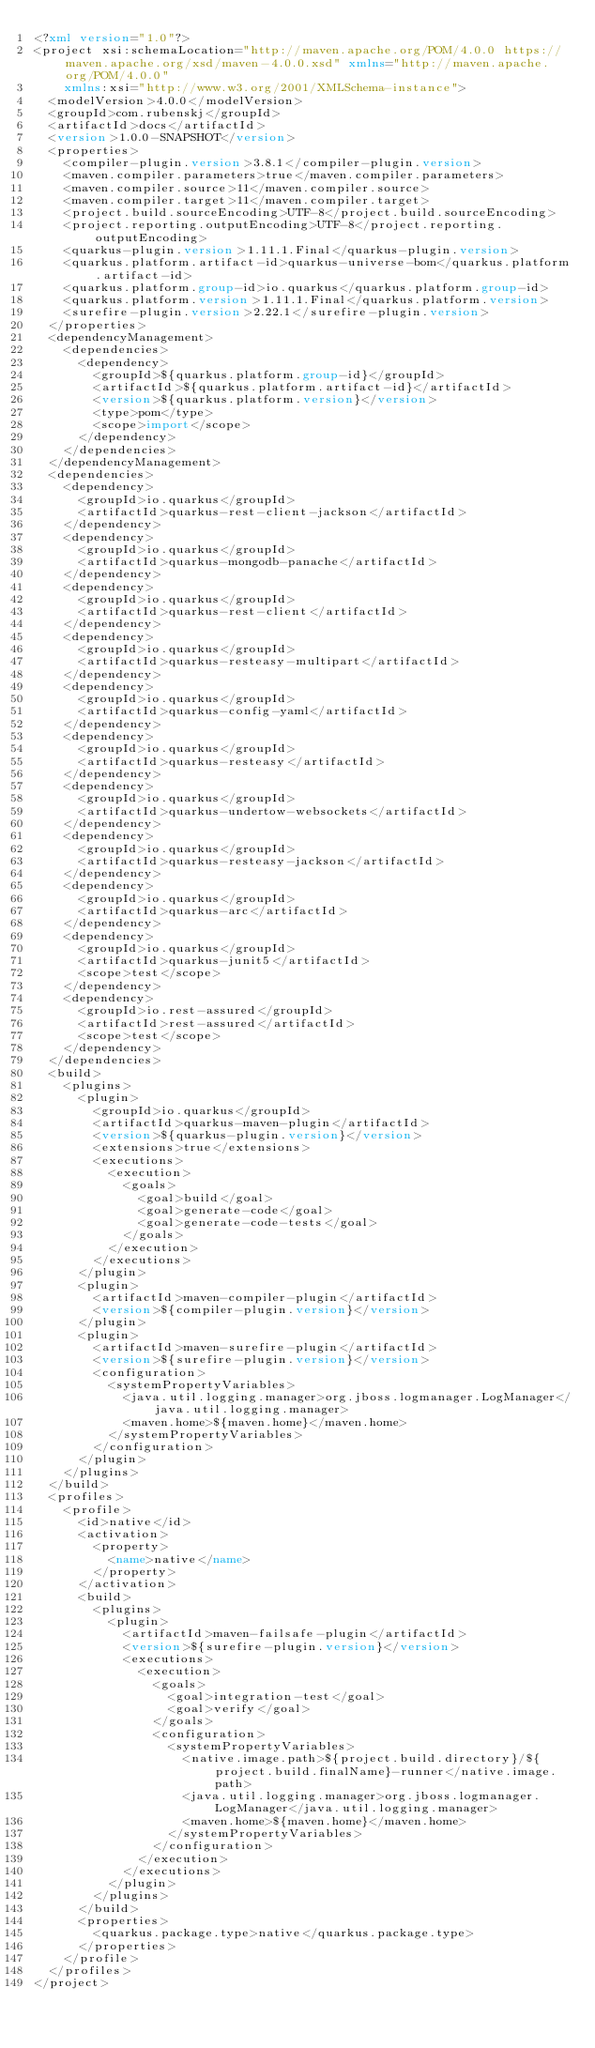Convert code to text. <code><loc_0><loc_0><loc_500><loc_500><_XML_><?xml version="1.0"?>
<project xsi:schemaLocation="http://maven.apache.org/POM/4.0.0 https://maven.apache.org/xsd/maven-4.0.0.xsd" xmlns="http://maven.apache.org/POM/4.0.0"
    xmlns:xsi="http://www.w3.org/2001/XMLSchema-instance">
  <modelVersion>4.0.0</modelVersion>
  <groupId>com.rubenskj</groupId>
  <artifactId>docs</artifactId>
  <version>1.0.0-SNAPSHOT</version>
  <properties>
    <compiler-plugin.version>3.8.1</compiler-plugin.version>
    <maven.compiler.parameters>true</maven.compiler.parameters>
    <maven.compiler.source>11</maven.compiler.source>
    <maven.compiler.target>11</maven.compiler.target>
    <project.build.sourceEncoding>UTF-8</project.build.sourceEncoding>
    <project.reporting.outputEncoding>UTF-8</project.reporting.outputEncoding>
    <quarkus-plugin.version>1.11.1.Final</quarkus-plugin.version>
    <quarkus.platform.artifact-id>quarkus-universe-bom</quarkus.platform.artifact-id>
    <quarkus.platform.group-id>io.quarkus</quarkus.platform.group-id>
    <quarkus.platform.version>1.11.1.Final</quarkus.platform.version>
    <surefire-plugin.version>2.22.1</surefire-plugin.version>
  </properties>
  <dependencyManagement>
    <dependencies>
      <dependency>
        <groupId>${quarkus.platform.group-id}</groupId>
        <artifactId>${quarkus.platform.artifact-id}</artifactId>
        <version>${quarkus.platform.version}</version>
        <type>pom</type>
        <scope>import</scope>
      </dependency>
    </dependencies>
  </dependencyManagement>
  <dependencies>
    <dependency>
      <groupId>io.quarkus</groupId>
      <artifactId>quarkus-rest-client-jackson</artifactId>
    </dependency>
    <dependency>
      <groupId>io.quarkus</groupId>
      <artifactId>quarkus-mongodb-panache</artifactId>
    </dependency>
    <dependency>
      <groupId>io.quarkus</groupId>
      <artifactId>quarkus-rest-client</artifactId>
    </dependency>
    <dependency>
      <groupId>io.quarkus</groupId>
      <artifactId>quarkus-resteasy-multipart</artifactId>
    </dependency>
    <dependency>
      <groupId>io.quarkus</groupId>
      <artifactId>quarkus-config-yaml</artifactId>
    </dependency>
    <dependency>
      <groupId>io.quarkus</groupId>
      <artifactId>quarkus-resteasy</artifactId>
    </dependency>
    <dependency>
      <groupId>io.quarkus</groupId>
      <artifactId>quarkus-undertow-websockets</artifactId>
    </dependency>
    <dependency>
      <groupId>io.quarkus</groupId>
      <artifactId>quarkus-resteasy-jackson</artifactId>
    </dependency>
    <dependency>
      <groupId>io.quarkus</groupId>
      <artifactId>quarkus-arc</artifactId>
    </dependency>
    <dependency>
      <groupId>io.quarkus</groupId>
      <artifactId>quarkus-junit5</artifactId>
      <scope>test</scope>
    </dependency>
    <dependency>
      <groupId>io.rest-assured</groupId>
      <artifactId>rest-assured</artifactId>
      <scope>test</scope>
    </dependency>
  </dependencies>
  <build>
    <plugins>
      <plugin>
        <groupId>io.quarkus</groupId>
        <artifactId>quarkus-maven-plugin</artifactId>
        <version>${quarkus-plugin.version}</version>
        <extensions>true</extensions>
        <executions>
          <execution>
            <goals>
              <goal>build</goal>
              <goal>generate-code</goal>
              <goal>generate-code-tests</goal>
            </goals>
          </execution>
        </executions>
      </plugin>
      <plugin>
        <artifactId>maven-compiler-plugin</artifactId>
        <version>${compiler-plugin.version}</version>
      </plugin>
      <plugin>
        <artifactId>maven-surefire-plugin</artifactId>
        <version>${surefire-plugin.version}</version>
        <configuration>
          <systemPropertyVariables>
            <java.util.logging.manager>org.jboss.logmanager.LogManager</java.util.logging.manager>
            <maven.home>${maven.home}</maven.home>
          </systemPropertyVariables>
        </configuration>
      </plugin>
    </plugins>
  </build>
  <profiles>
    <profile>
      <id>native</id>
      <activation>
        <property>
          <name>native</name>
        </property>
      </activation>
      <build>
        <plugins>
          <plugin>
            <artifactId>maven-failsafe-plugin</artifactId>
            <version>${surefire-plugin.version}</version>
            <executions>
              <execution>
                <goals>
                  <goal>integration-test</goal>
                  <goal>verify</goal>
                </goals>
                <configuration>
                  <systemPropertyVariables>
                    <native.image.path>${project.build.directory}/${project.build.finalName}-runner</native.image.path>
                    <java.util.logging.manager>org.jboss.logmanager.LogManager</java.util.logging.manager>
                    <maven.home>${maven.home}</maven.home>
                  </systemPropertyVariables>
                </configuration>
              </execution>
            </executions>
          </plugin>
        </plugins>
      </build>
      <properties>
        <quarkus.package.type>native</quarkus.package.type>
      </properties>
    </profile>
  </profiles>
</project>
</code> 